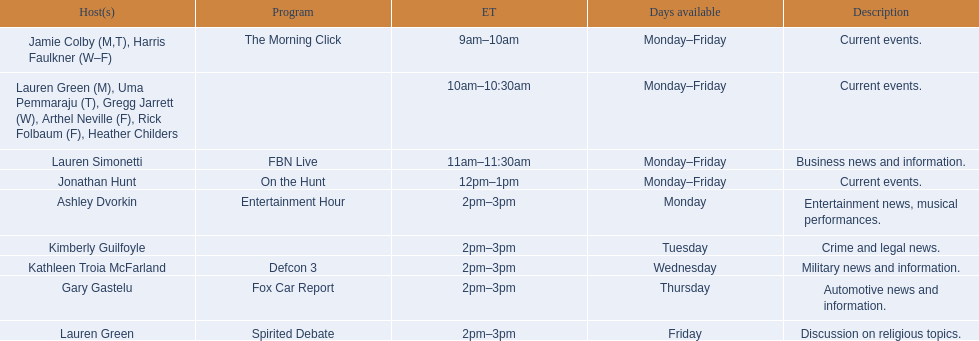Who are all of the hosts? Jamie Colby (M,T), Harris Faulkner (W–F), Lauren Green (M), Uma Pemmaraju (T), Gregg Jarrett (W), Arthel Neville (F), Rick Folbaum (F), Heather Childers, Lauren Simonetti, Jonathan Hunt, Ashley Dvorkin, Kimberly Guilfoyle, Kathleen Troia McFarland, Gary Gastelu, Lauren Green. Which hosts have shows on fridays? Jamie Colby (M,T), Harris Faulkner (W–F), Lauren Green (M), Uma Pemmaraju (T), Gregg Jarrett (W), Arthel Neville (F), Rick Folbaum (F), Heather Childers, Lauren Simonetti, Jonathan Hunt, Lauren Green. Of those, which host's show airs at 2pm? Lauren Green. Could you parse the entire table as a dict? {'header': ['Host(s)', 'Program', 'ET', 'Days available', 'Description'], 'rows': [['Jamie Colby (M,T), Harris Faulkner (W–F)', 'The Morning Click', '9am–10am', 'Monday–Friday', 'Current events.'], ['Lauren Green (M), Uma Pemmaraju (T), Gregg Jarrett (W), Arthel Neville (F), Rick Folbaum (F), Heather Childers', '', '10am–10:30am', 'Monday–Friday', 'Current events.'], ['Lauren Simonetti', 'FBN Live', '11am–11:30am', 'Monday–Friday', 'Business news and information.'], ['Jonathan Hunt', 'On the Hunt', '12pm–1pm', 'Monday–Friday', 'Current events.'], ['Ashley Dvorkin', 'Entertainment Hour', '2pm–3pm', 'Monday', 'Entertainment news, musical performances.'], ['Kimberly Guilfoyle', '', '2pm–3pm', 'Tuesday', 'Crime and legal news.'], ['Kathleen Troia McFarland', 'Defcon 3', '2pm–3pm', 'Wednesday', 'Military news and information.'], ['Gary Gastelu', 'Fox Car Report', '2pm–3pm', 'Thursday', 'Automotive news and information.'], ['Lauren Green', 'Spirited Debate', '2pm–3pm', 'Friday', 'Discussion on religious topics.']]} 